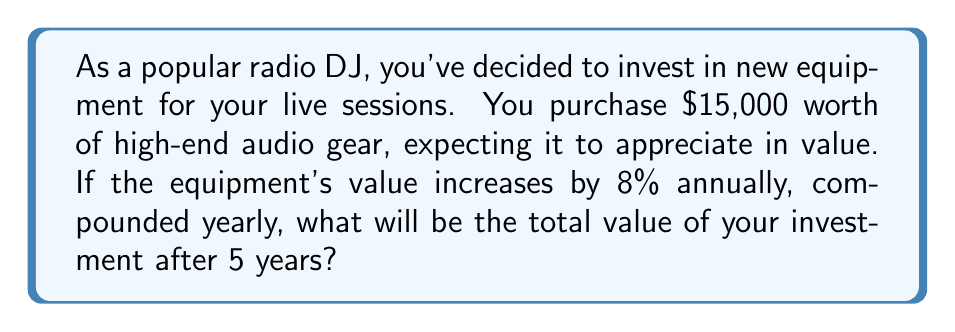Show me your answer to this math problem. To solve this problem, we'll use the compound interest formula:

$$A = P(1 + r)^n$$

Where:
$A$ = Final amount
$P$ = Principal (initial investment)
$r$ = Annual interest rate (as a decimal)
$n$ = Number of years

Given:
$P = $15,000
$r = 8\% = 0.08$
$n = 5$ years

Let's substitute these values into the formula:

$$A = 15000(1 + 0.08)^5$$

Now, let's calculate step by step:

1) First, calculate $(1 + 0.08)$:
   $1 + 0.08 = 1.08$

2) Now, raise 1.08 to the power of 5:
   $1.08^5 \approx 1.469328$

3) Finally, multiply this by the principal:
   $15000 \times 1.469328 \approx 22039.92$

Therefore, after 5 years, the equipment will be worth approximately $22,039.92.
Answer: $22,039.92 